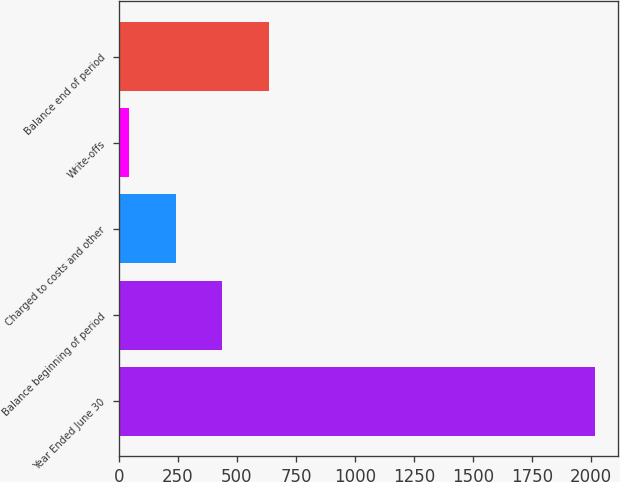<chart> <loc_0><loc_0><loc_500><loc_500><bar_chart><fcel>Year Ended June 30<fcel>Balance beginning of period<fcel>Charged to costs and other<fcel>Write-offs<fcel>Balance end of period<nl><fcel>2015<fcel>437.4<fcel>240.2<fcel>43<fcel>634.6<nl></chart> 